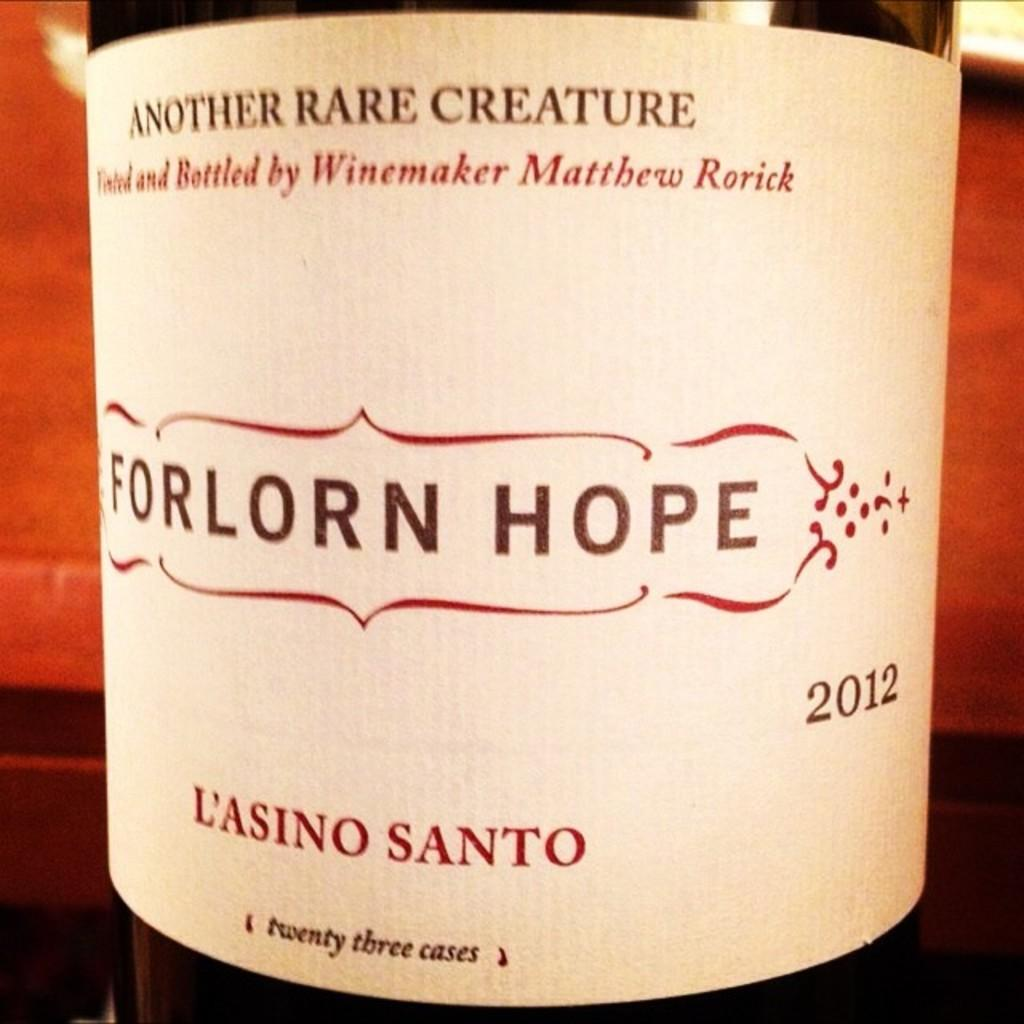<image>
Create a compact narrative representing the image presented. A 2012 bottle of L'ASINO SANTO sits in front of a stone wall. 